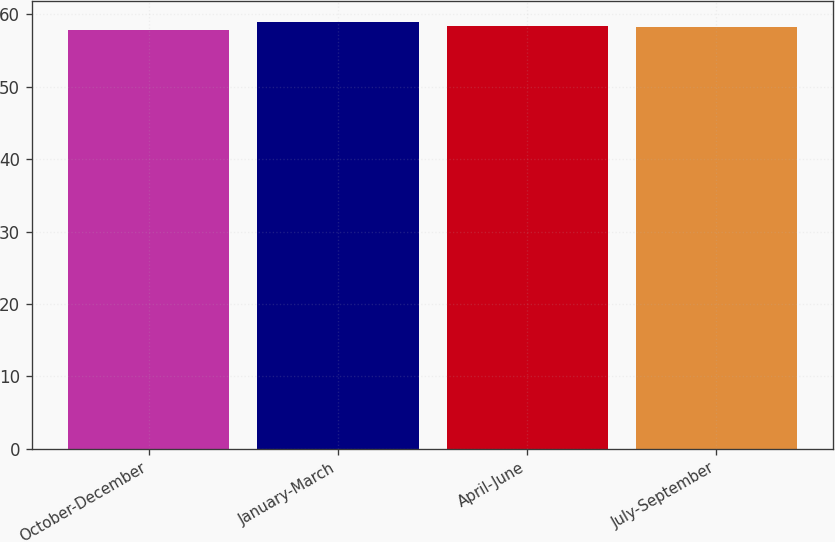Convert chart. <chart><loc_0><loc_0><loc_500><loc_500><bar_chart><fcel>October-December<fcel>January-March<fcel>April-June<fcel>July-September<nl><fcel>57.85<fcel>58.87<fcel>58.42<fcel>58.28<nl></chart> 